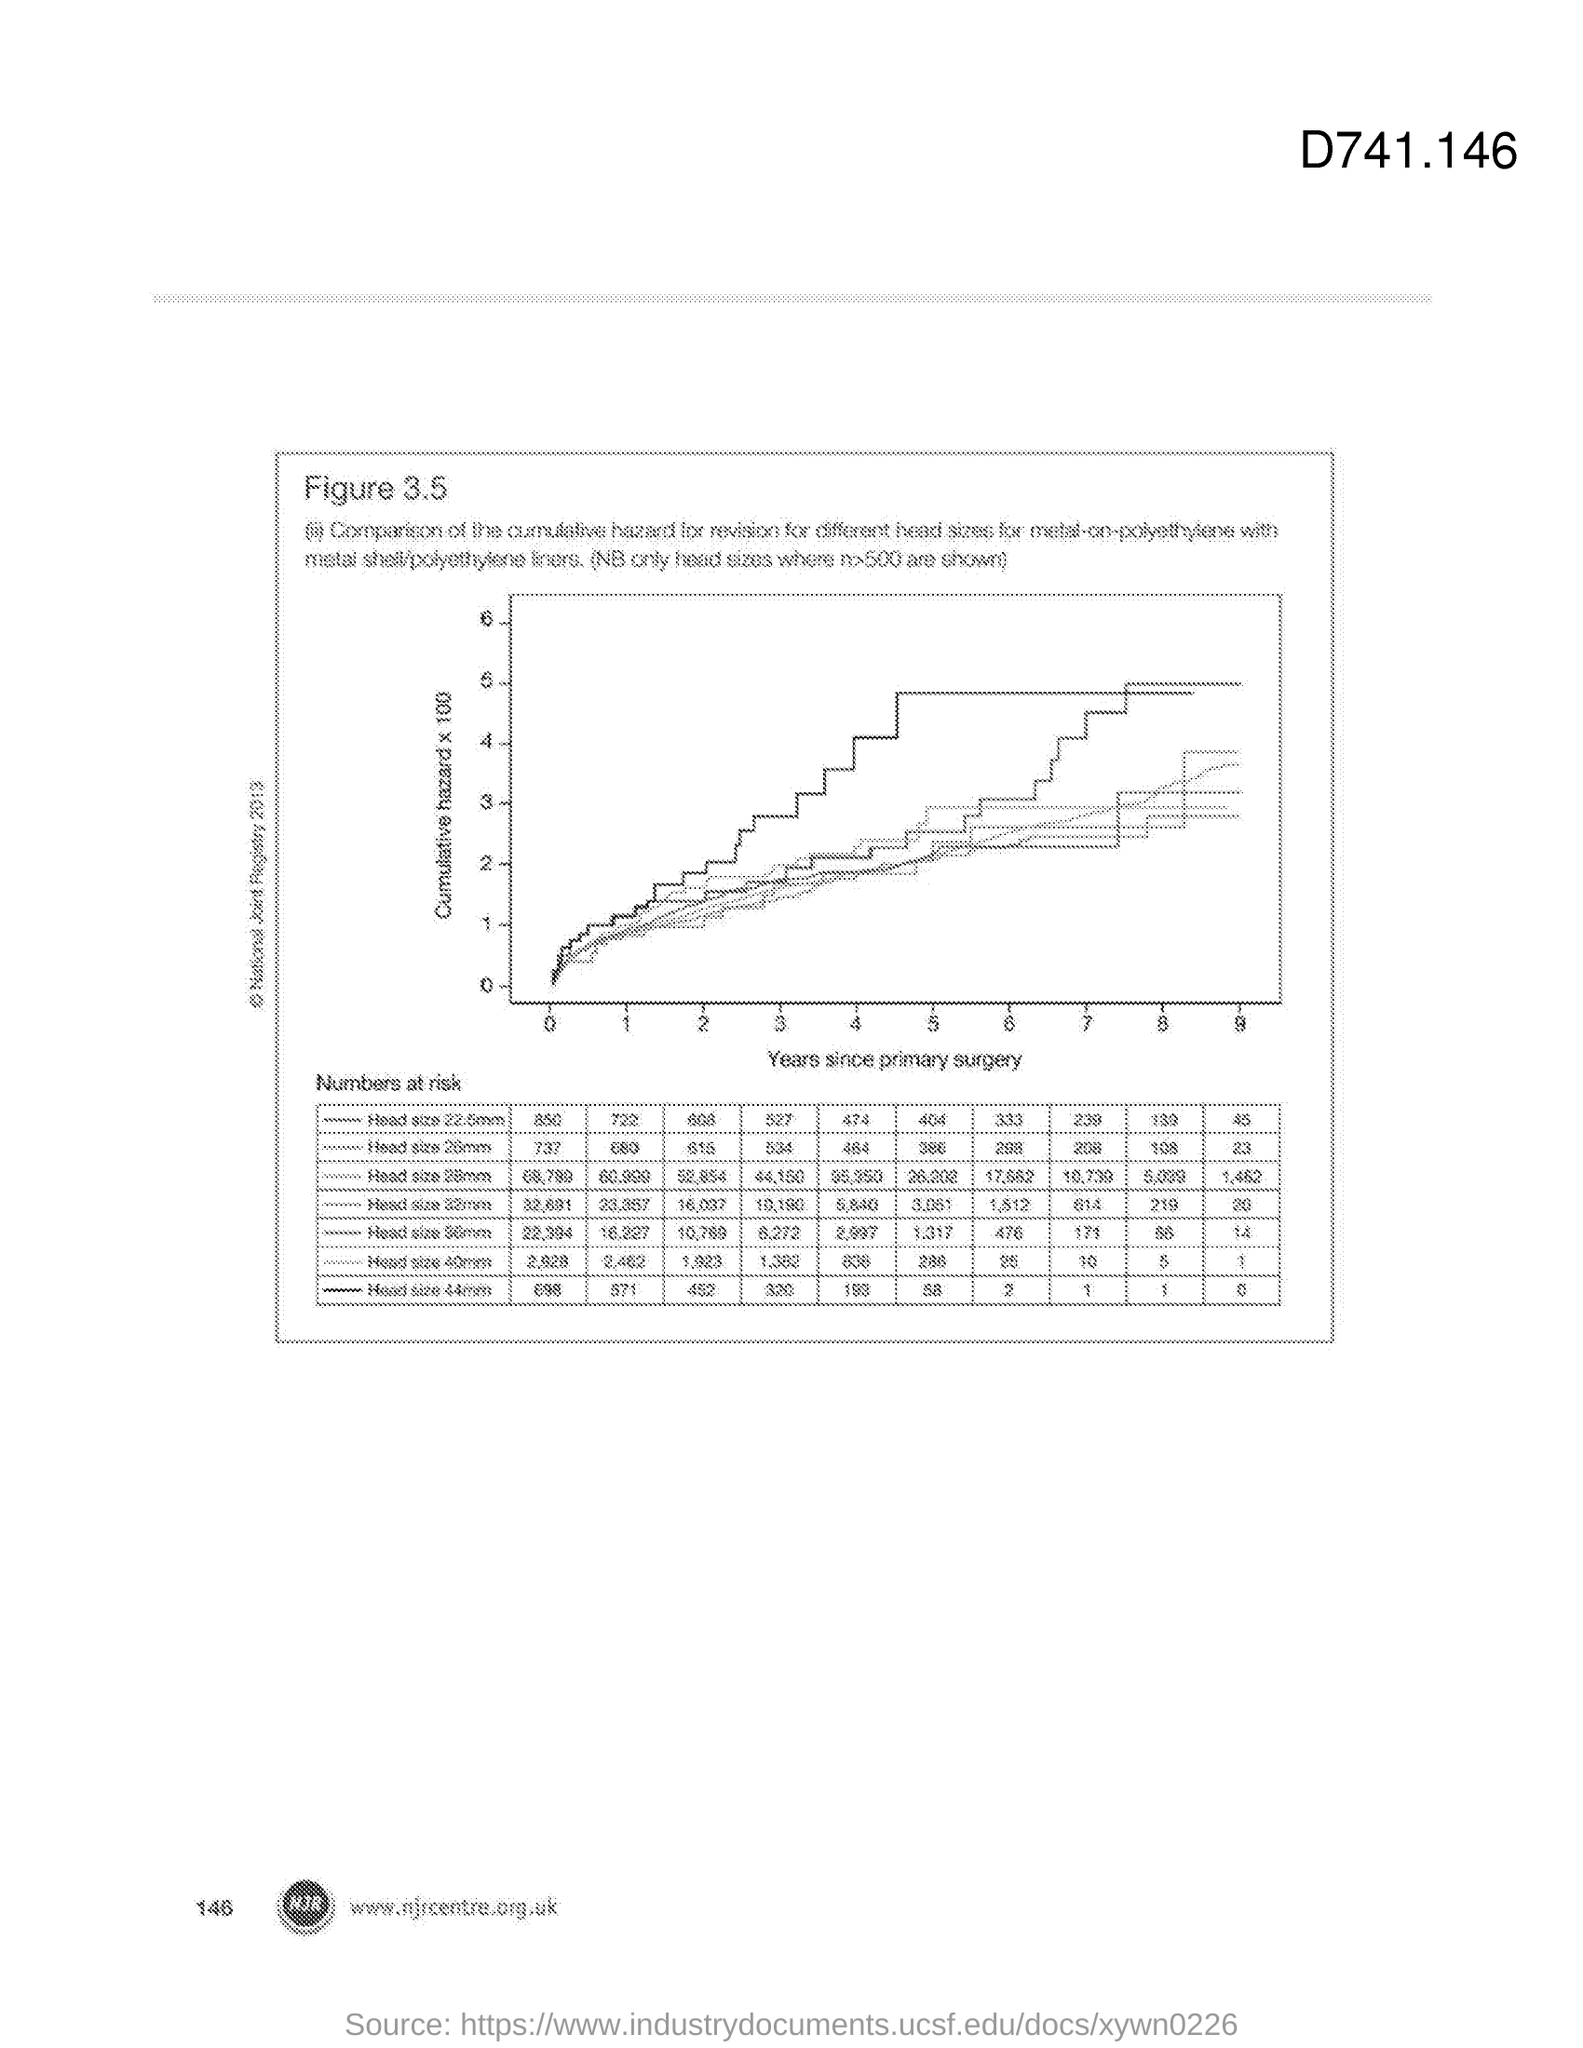Specify some key components in this picture. The cumulative hazard is plotted on the y-axis, which means that the graph shows the probability of an event happening over time, multiplied by 100. The x-axis in the plot shows the years since the patient's primary surgery. 